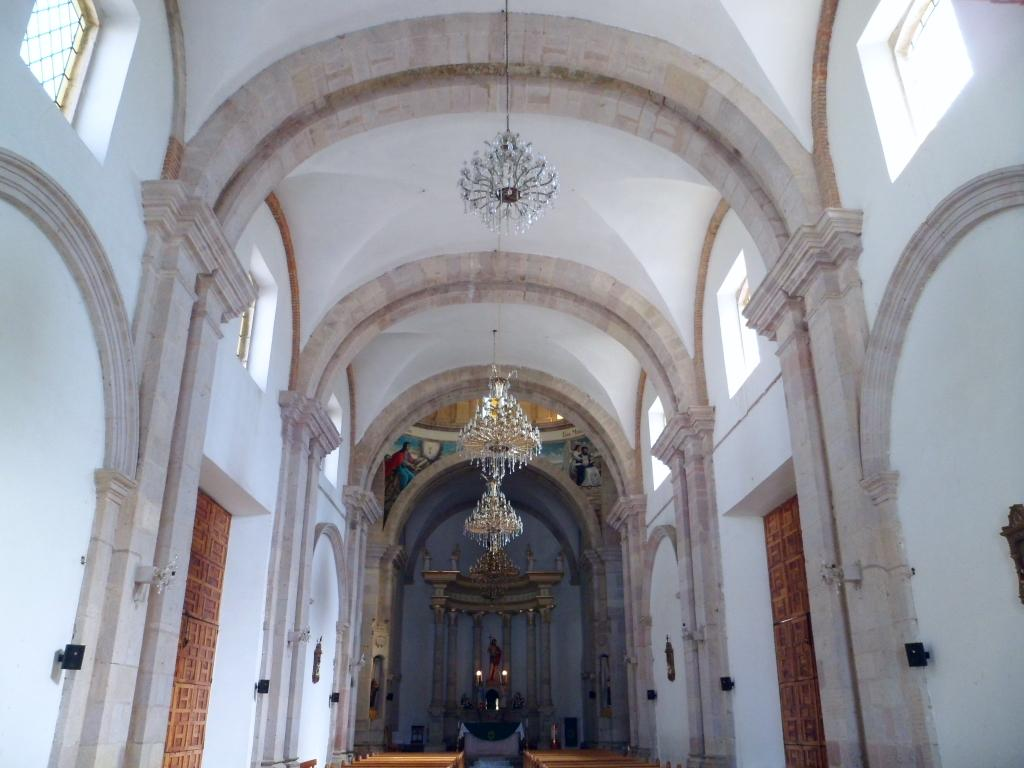What type of lighting fixture can be seen in the image? There are chandeliers hanging in the image. What architectural features are present in the image? There are doors and walls in the image. What can be seen in the background of the image? There is a statue in the background of the image. What type of openings are present at the top of the image? There are windows at the top of the image. What type of scarf is draped over the statue in the image? There is no scarf present in the image; the statue is not wearing or holding any clothing or accessories. What country is depicted in the image? The image does not depict any specific country; it only shows architectural features and a statue. 